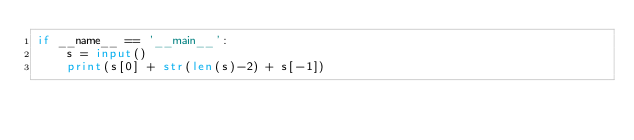Convert code to text. <code><loc_0><loc_0><loc_500><loc_500><_Python_>if __name__ == '__main__':
    s = input()
    print(s[0] + str(len(s)-2) + s[-1])
</code> 